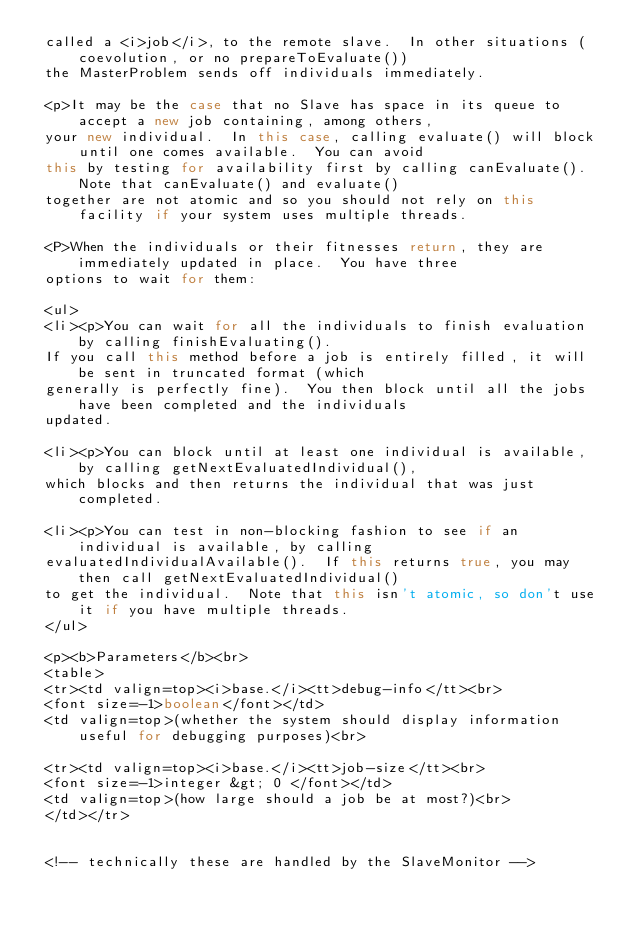<code> <loc_0><loc_0><loc_500><loc_500><_Java_> called a <i>job</i>, to the remote slave.  In other situations (coevolution, or no prepareToEvaluate())
 the MasterProblem sends off individuals immediately.

 <p>It may be the case that no Slave has space in its queue to accept a new job containing, among others,
 your new individual.  In this case, calling evaluate() will block until one comes available.  You can avoid
 this by testing for availability first by calling canEvaluate().  Note that canEvaluate() and evaluate()
 together are not atomic and so you should not rely on this facility if your system uses multiple threads.

 <P>When the individuals or their fitnesses return, they are immediately updated in place.  You have three
 options to wait for them:

 <ul>
 <li><p>You can wait for all the individuals to finish evaluation by calling finishEvaluating().
 If you call this method before a job is entirely filled, it will be sent in truncated format (which
 generally is perfectly fine).  You then block until all the jobs have been completed and the individuals
 updated.

 <li><p>You can block until at least one individual is available, by calling getNextEvaluatedIndividual(),
 which blocks and then returns the individual that was just completed.

 <li><p>You can test in non-blocking fashion to see if an individual is available, by calling
 evaluatedIndividualAvailable().  If this returns true, you may then call getNextEvaluatedIndividual()
 to get the individual.  Note that this isn't atomic, so don't use it if you have multiple threads.
 </ul>

 <p><b>Parameters</b><br>
 <table>
 <tr><td valign=top><i>base.</i><tt>debug-info</tt><br>
 <font size=-1>boolean</font></td>
 <td valign=top>(whether the system should display information useful for debugging purposes)<br>

 <tr><td valign=top><i>base.</i><tt>job-size</tt><br>
 <font size=-1>integer &gt; 0 </font></td>
 <td valign=top>(how large should a job be at most?)<br>
 </td></tr>


 <!-- technically these are handled by the SlaveMonitor -->
</code> 